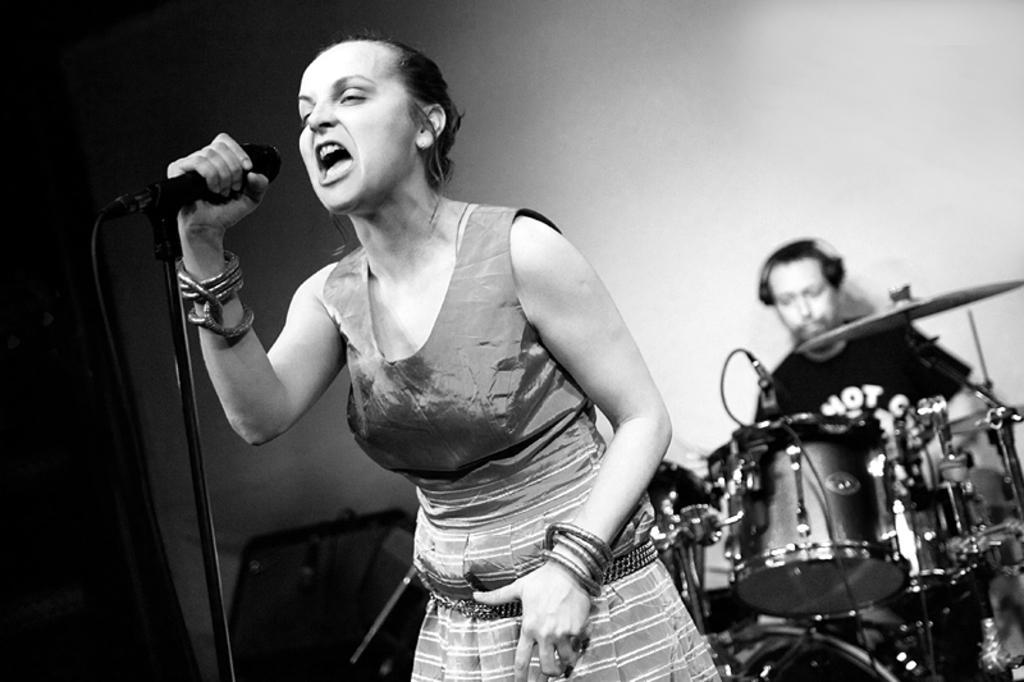How would you summarize this image in a sentence or two? This image is taken in a concert. In this image there are two people a man and a woman. In the middle of the image there is a woman standing and holding a mic in her hand and singing. In the right side of the image a man is sitting on a stool and playing drums. 